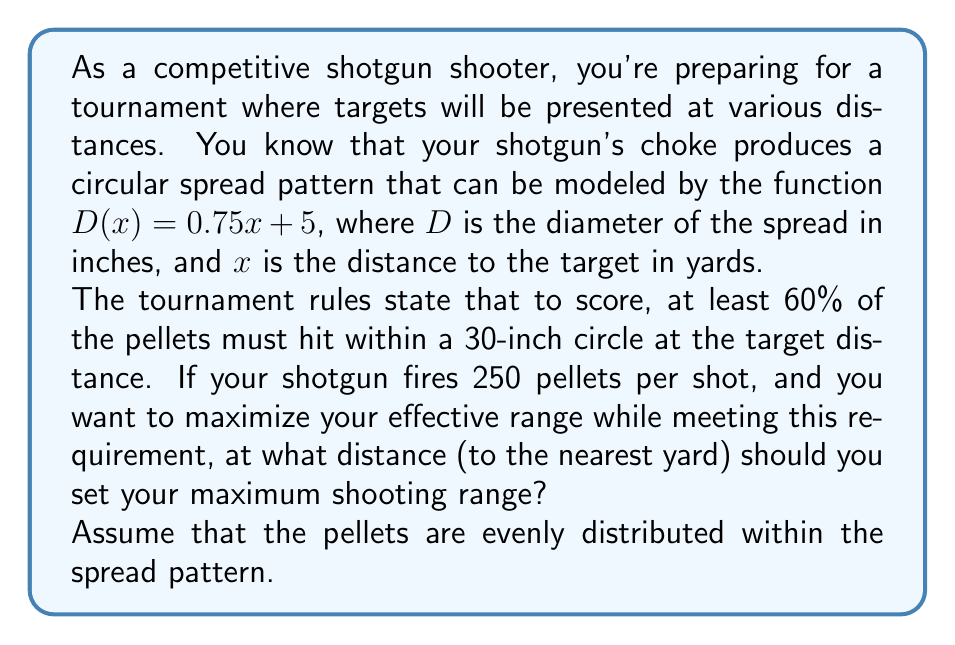Help me with this question. Let's approach this step-by-step:

1) First, we need to determine the relationship between the spread diameter and the percentage of pellets within a 30-inch circle.

2) The area of the spread pattern is $A_s = \pi(\frac{D}{2})^2$, where $D$ is the diameter.

3) The area of the 30-inch scoring circle is $A_c = \pi(15)^2 = 225\pi$ square inches.

4) The ratio of these areas will give us the percentage of pellets in the scoring circle:

   $\frac{A_c}{A_s} = \frac{225\pi}{\pi(\frac{D}{2})^2} = \frac{900}{D^2}$

5) We want this ratio to be 0.60 (60%):

   $\frac{900}{D^2} = 0.60$

6) Solving for $D$:

   $D^2 = \frac{900}{0.60} = 1500$
   $D = \sqrt{1500} \approx 38.73$ inches

7) Now we can use our spread function to find the distance:

   $38.73 = 0.75x + 5$
   $33.73 = 0.75x$
   $x = 44.97$ yards

8) Rounding to the nearest yard gives us 45 yards.

Therefore, to ensure that 60% of the pellets hit within a 30-inch circle, the maximum shooting range should be set to 45 yards.
Answer: 45 yards 